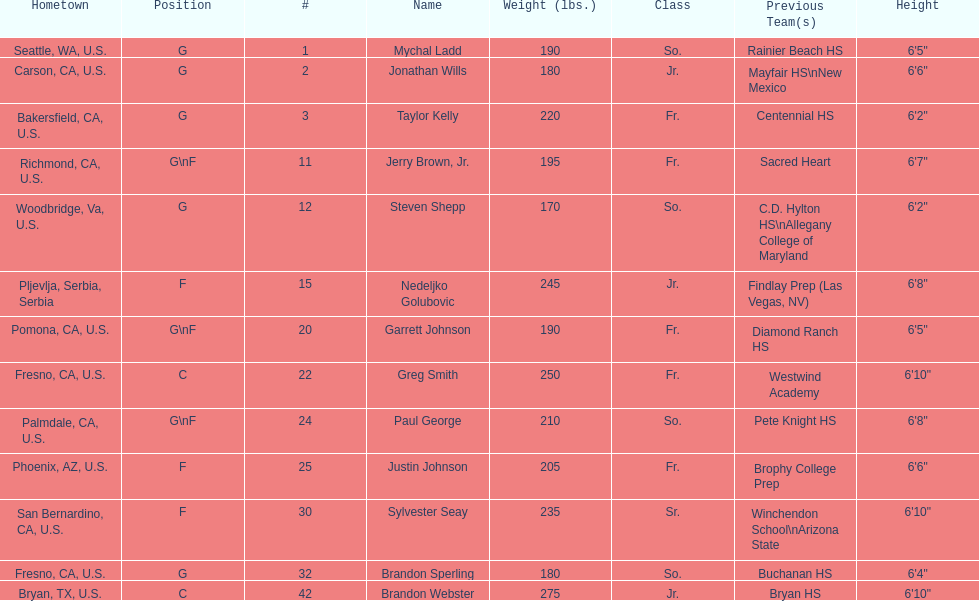Which player is taller, paul george or greg smith? Greg Smith. 